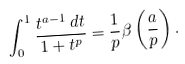Convert formula to latex. <formula><loc_0><loc_0><loc_500><loc_500>\int _ { 0 } ^ { 1 } \frac { t ^ { a - 1 } \, d t } { 1 + t ^ { p } } = \frac { 1 } { p } \beta \left ( \frac { a } { p } \right ) .</formula> 